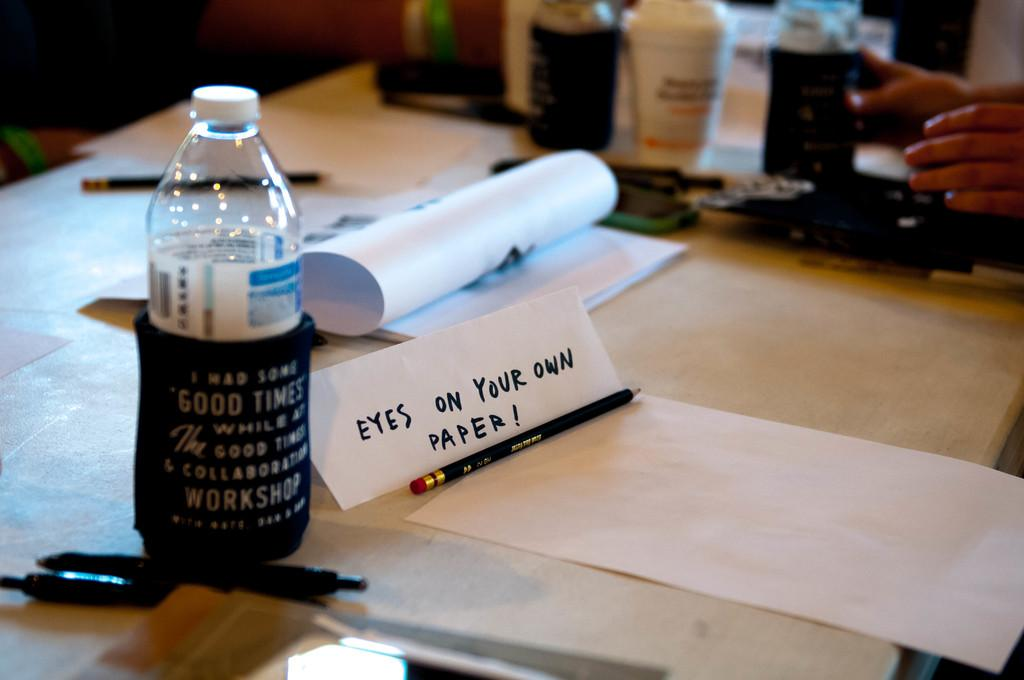What type of table is in the image? There is a white table in the image. What is on top of the table? There is a bottle, a book, objects, a pen, and a pencil on the table. Can you describe the objects on the table? The objects on the table include a bottle, a book, a pen, and a pencil. What type of badge is the man wearing in the image? There is no man or badge present in the image; it only features a white table with various objects on it. 